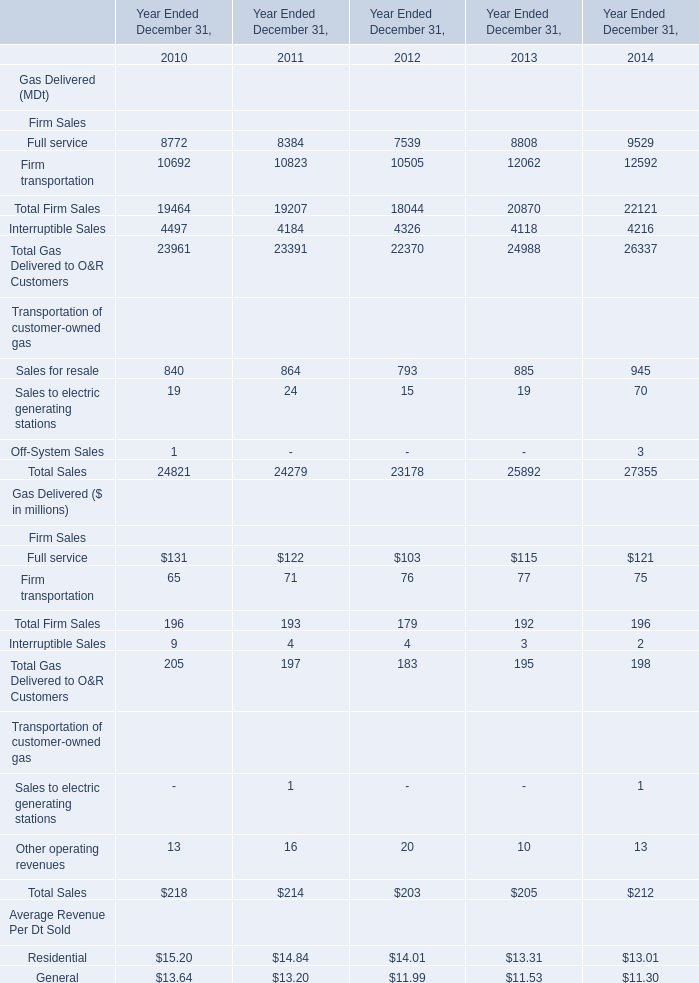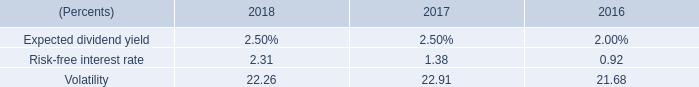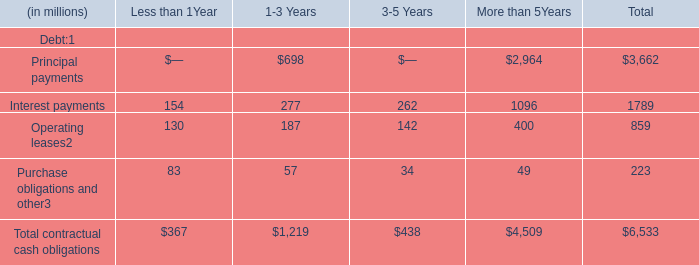Does the value of Firm transportation in 2012 greater than that in 2013 ? 
Answer: No. 